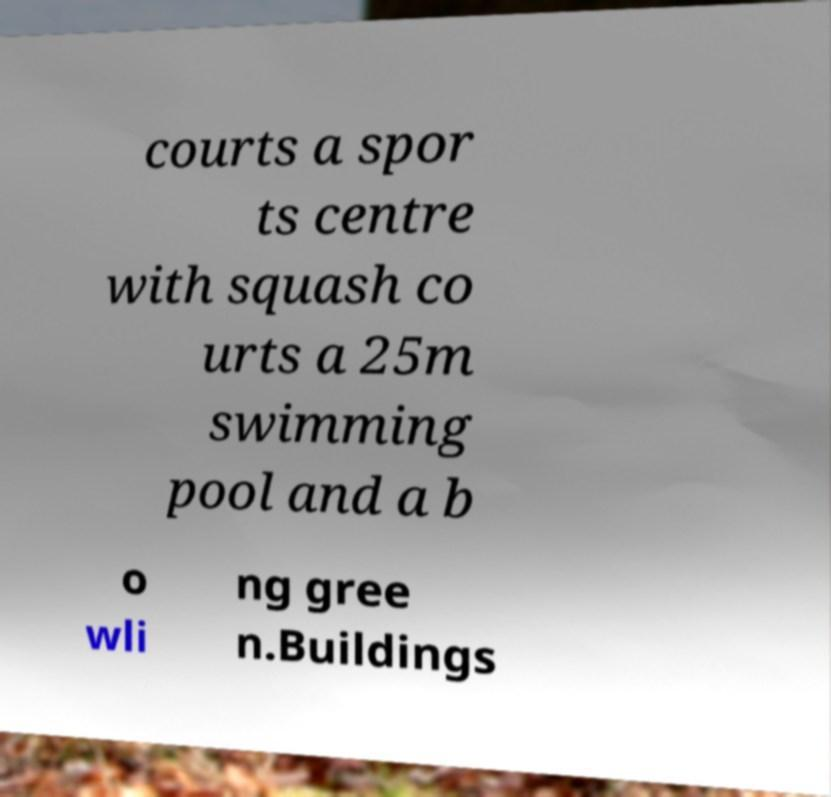I need the written content from this picture converted into text. Can you do that? courts a spor ts centre with squash co urts a 25m swimming pool and a b o wli ng gree n.Buildings 